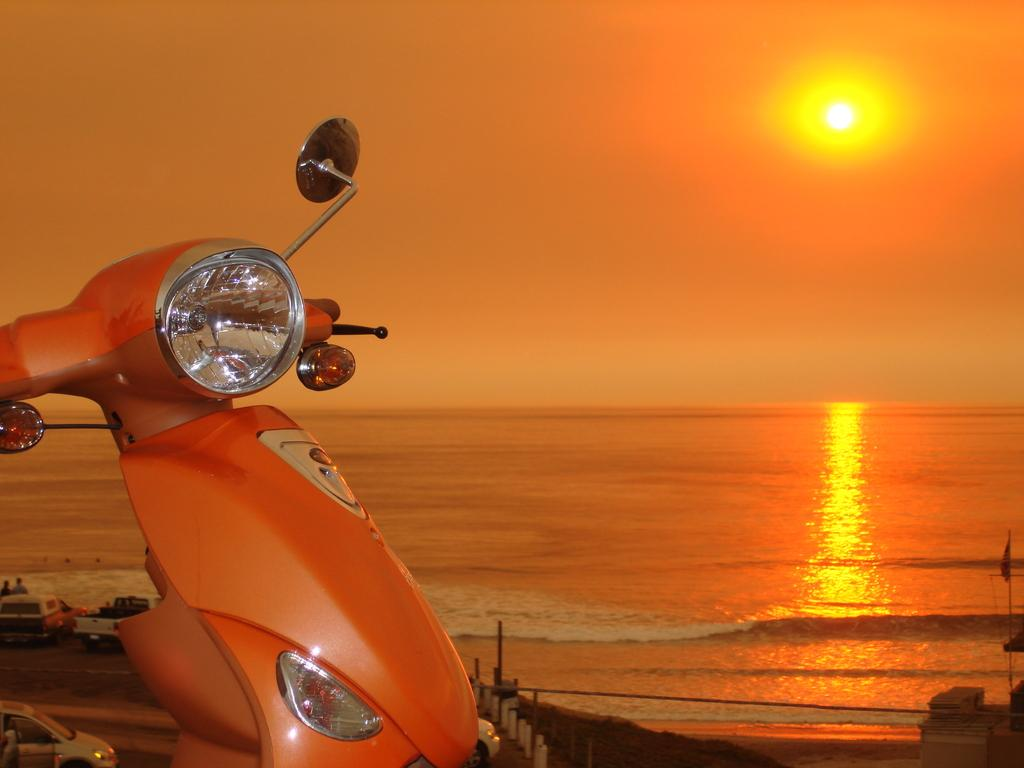What type of natural body of water is visible in the image? There is an ocean in the image. What object can be seen on the left side of the image? There is a bike on the left side of the image. What part of the sky is visible in the image? The sky is visible in the image. What celestial body is present in the sky? The sun is present in the sky. What color is the sky in the image? The sky has an orange color. How many eyes does the ocean have in the image? The ocean does not have eyes; it is a natural body of water. Can you see any wings in the image? There are no wings visible in the image. 